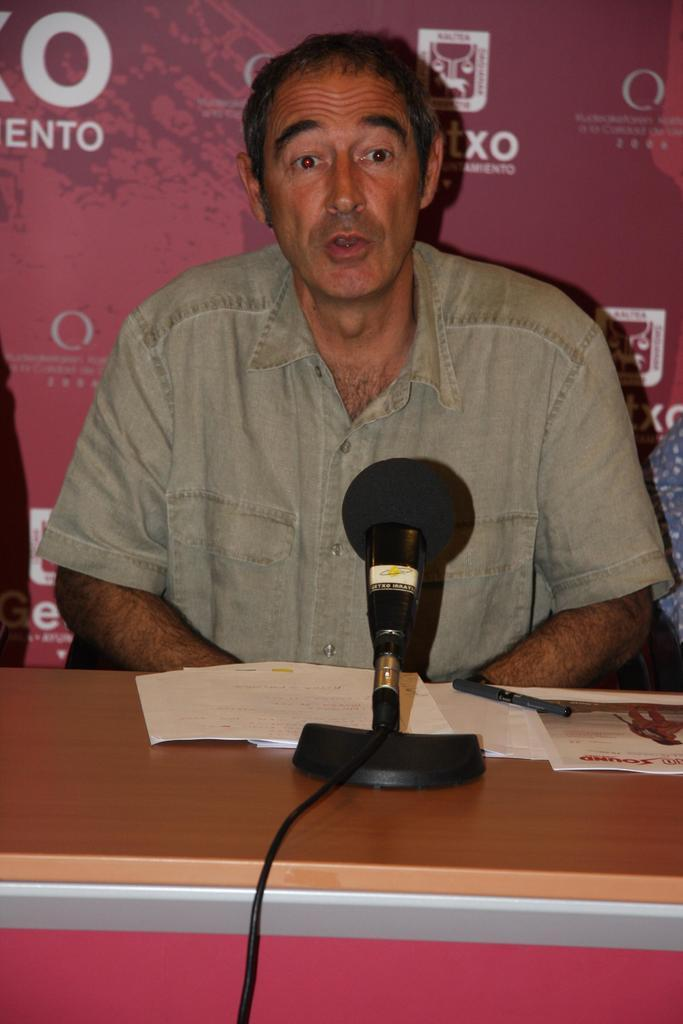What is the person in the image doing? The person is sitting in a chair, and their mouth is open, indicating they are talking. What objects are on the table in the image? There is a microphone (mic), a paper, and a wire on the table. What is the purpose of the microphone in the image? The microphone is likely used for amplifying the person's voice while they are talking. What type of toothbrush is the person using in the image? There is no toothbrush present in the image. What event is the person attending in the image? The image does not provide any information about an event or show that the person might be attending. 